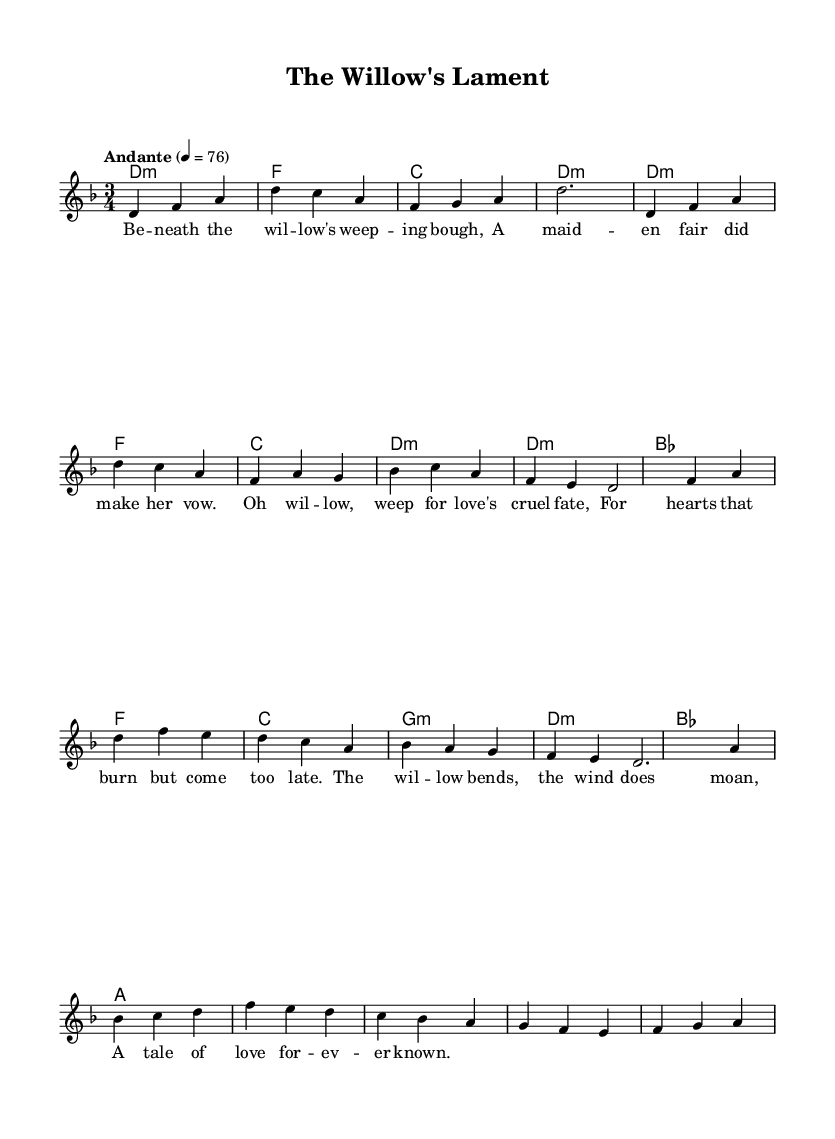What is the key signature of this music? The key signature is represented by the 'd' symbol in the code, indicating it has two flats. The music is written in D minor, which has one flat associated with its relative major, F major.
Answer: D minor What is the time signature of this music? The time signature is shown with the '3/4' notation in the code, which indicates that there are three beats per measure and the quarter note gets one beat.
Answer: 3/4 What is the tempo marking of this music? The tempo marking is indicated with "Andante" in the code, which suggests a moderate walking pace, typically around 76 beats per minute as noted in the score.
Answer: Andante How many lines are present in the vocal melody? By examining the lyrics and associated melody, it is clear that the vocal melody flows over multiple staves with the lyrics articulated over the music. In this piece, there are three distinct sections (verse, chorus, bridge), indicating a structure with three main lines.
Answer: Three What is the primary theme expressed in the chorus? The chorus lyrics speak about love and its cruel fate, expressed through the metaphor of the willow weeping for lost love, thus indicating the emotional context conveyed in this traditional ballad.
Answer: Love's cruel fate How does the bridge contribute to the overall narrative of the ballad? The bridge emphasizes the sorrow and timelessness of the narrative, as the willow bending and the moaning wind evoke a sense of lamentation that connects with the themes of love and loss woven throughout the ballad. This deepens the tragic atmosphere.
Answer: A tale of love forever known What type of song structure is primarily used in this music? The structure follows a traditional folk song format, which typically encompasses verses followed by a repeating chorus, and in this case, also includes a bridge that enhances the storytelling aspect of the ballad.
Answer: Verse-Chorus-Bridge 